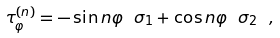<formula> <loc_0><loc_0><loc_500><loc_500>\tau _ { \varphi } ^ { ( n ) } = - \sin n \varphi \ \sigma _ { 1 } + \cos n \varphi \ \sigma _ { 2 } \ ,</formula> 